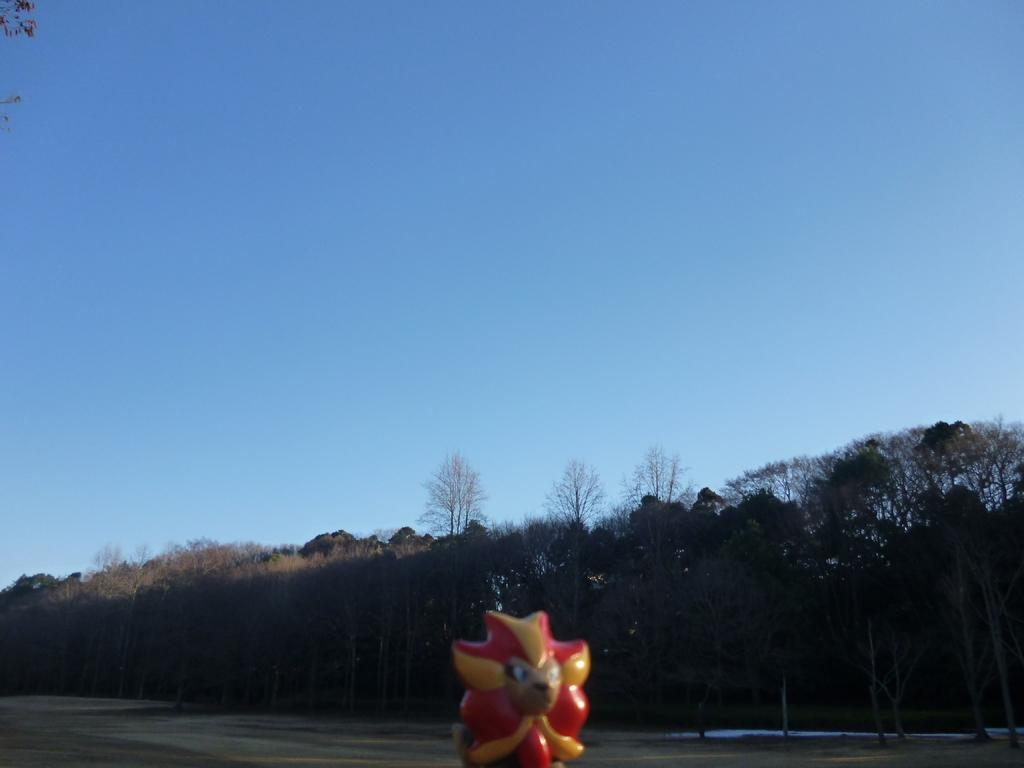What object can be seen in the image? There is a toy in the image. What is visible behind the toy? The ground is visible behind the toy. What can be seen in the distance in the image? There are trees, rocks, and the sky visible in the background of the image. Can you see a robin holding onto the toy in the image? There is no robin present in the image. How does the toy help the child grip objects better? The image does not provide information about the toy's function or how it might help a child grip objects. 